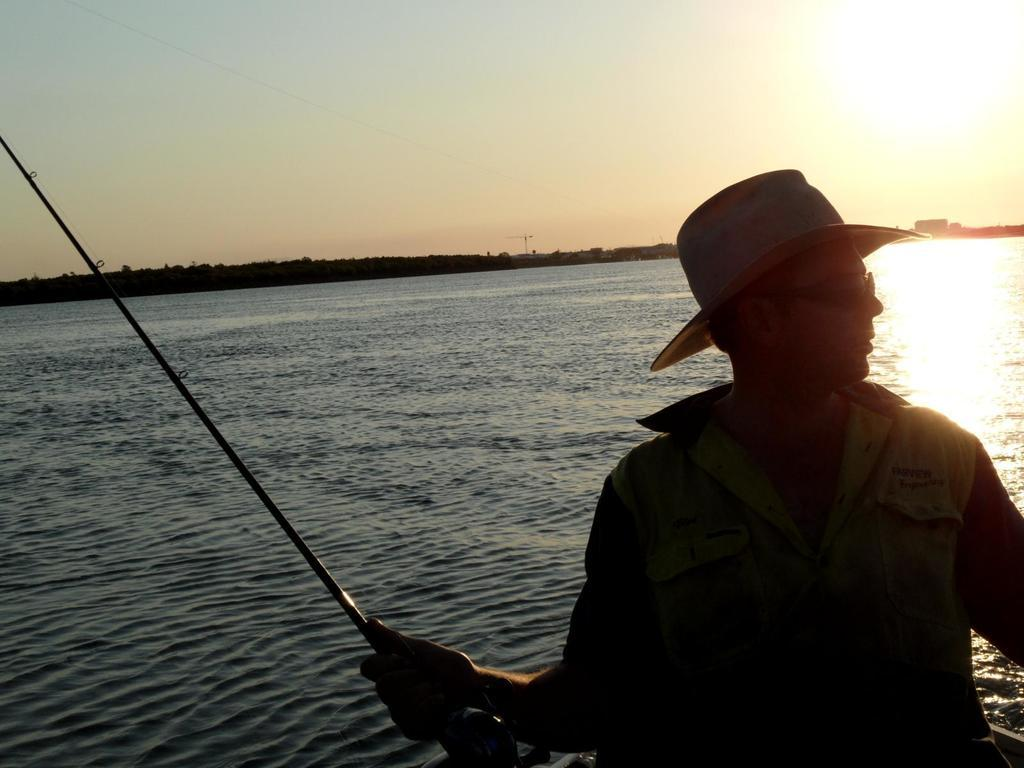What is the main subject of the image? The main subject of the image is a man. What is the man holding in his hand? The man is holding a stick in his hand. What type of headwear is the man wearing? The man is wearing a cap. What type of eye protection is the man wearing? The man is wearing goggles. What can be seen in the background of the image? Water, trees, and the sky are visible in the background of the image. What type of pig is the judge holding in the image? There is no pig or judge present in the image. Is the man playing baseball in the image? There is no indication of baseball or any related equipment in the image. 